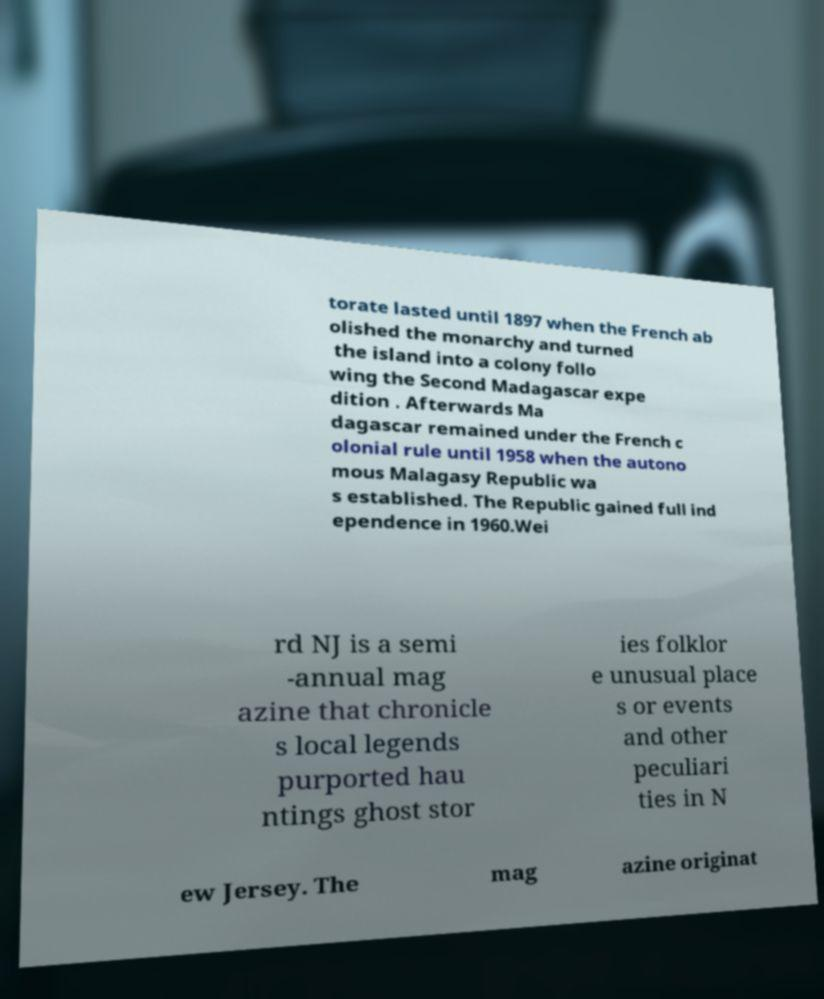Can you read and provide the text displayed in the image?This photo seems to have some interesting text. Can you extract and type it out for me? torate lasted until 1897 when the French ab olished the monarchy and turned the island into a colony follo wing the Second Madagascar expe dition . Afterwards Ma dagascar remained under the French c olonial rule until 1958 when the autono mous Malagasy Republic wa s established. The Republic gained full ind ependence in 1960.Wei rd NJ is a semi -annual mag azine that chronicle s local legends purported hau ntings ghost stor ies folklor e unusual place s or events and other peculiari ties in N ew Jersey. The mag azine originat 